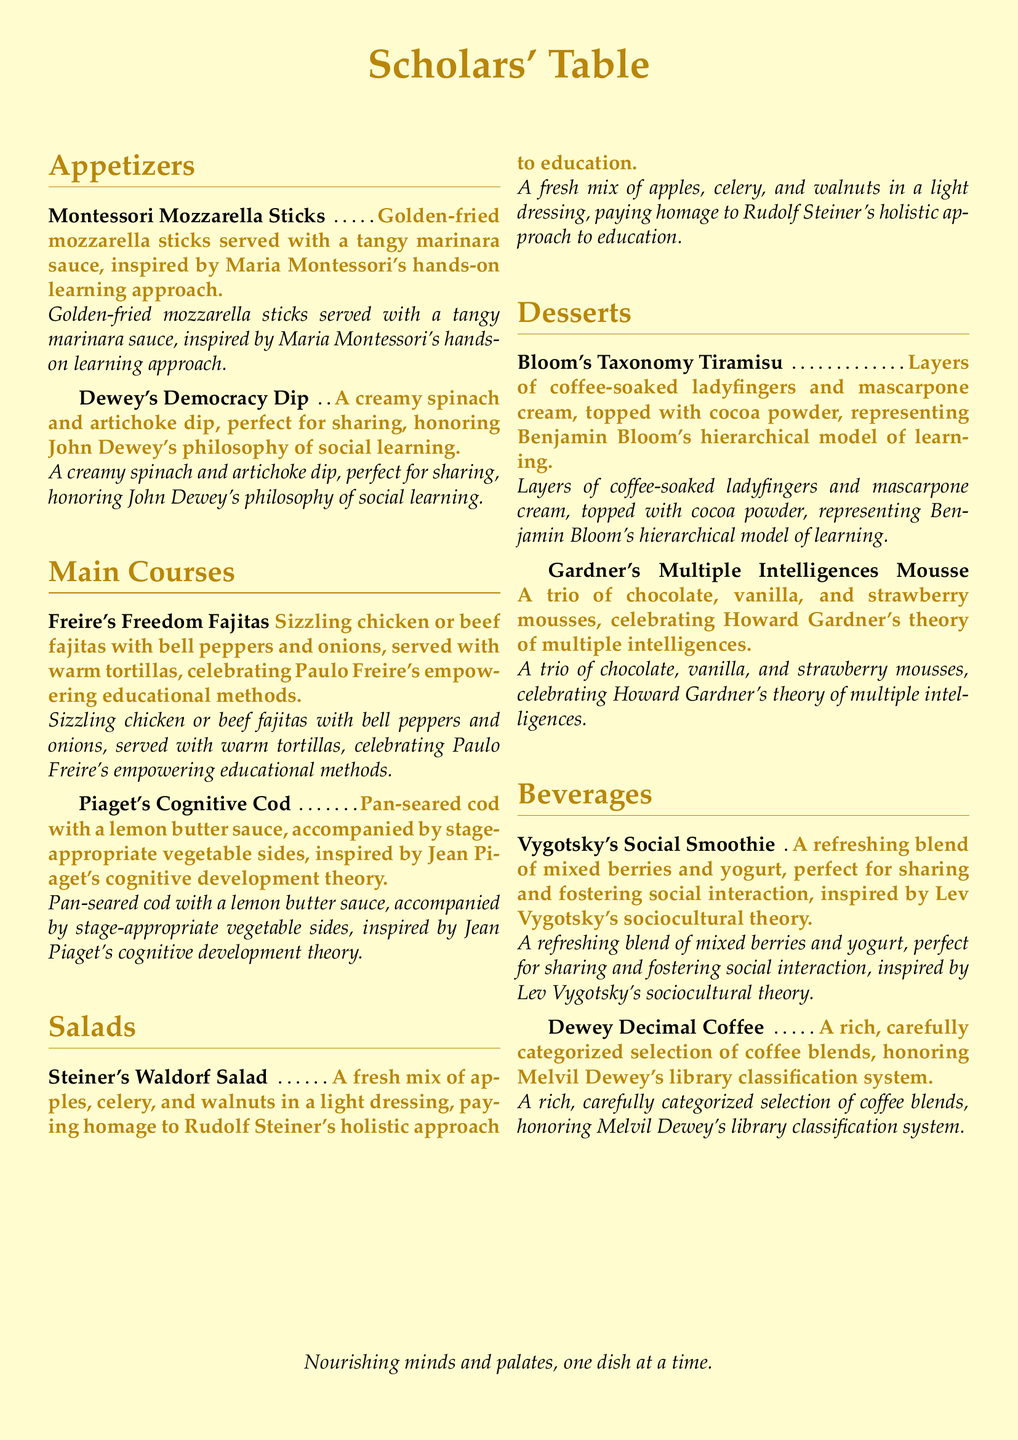What is the name of the appetizer inspired by Maria Montessori? The document lists "Montessori Mozzarella Sticks" as an appetizer inspired by Maria Montessori.
Answer: Montessori Mozzarella Sticks Which dessert represents Benjamin Bloom's model of learning? The dessert that represents Benjamin Bloom's hierarchical model of learning is "Bloom's Taxonomy Tiramisu."
Answer: Bloom's Taxonomy Tiramisu What type of dish is "Freire's Freedom Fajitas"? This dish is categorized under the Main Courses in the menu.
Answer: Main Courses How many types of mousse are featured in the desserts? The dessert named "Gardner's Multiple Intelligences Mousse" features three types of mousse: chocolate, vanilla, and strawberry.
Answer: Three What is the primary ingredient in the "Dewey's Democracy Dip"? The primary ingredients in "Dewey's Democracy Dip" are spinach and artichoke.
Answer: Spinach and artichoke Which figure is honored by the beverage named "Dewey Decimal Coffee"? The beverage "Dewey Decimal Coffee" honors Melvil Dewey.
Answer: Melvil Dewey What is the main vegetable side accompanying "Piaget's Cognitive Cod"? The document mentions "stage-appropriate vegetable sides" with Piaget's Cognitive Cod without specifying the exact vegetables.
Answer: Stage-appropriate vegetable sides Which salad is associated with Rudolf Steiner? The salad associated with Rudolf Steiner is "Steiner's Waldorf Salad."
Answer: Steiner's Waldorf Salad What color is the accent used in the menu title? The accent color used in the menu title "Scholars' Table" is gold.
Answer: Gold 